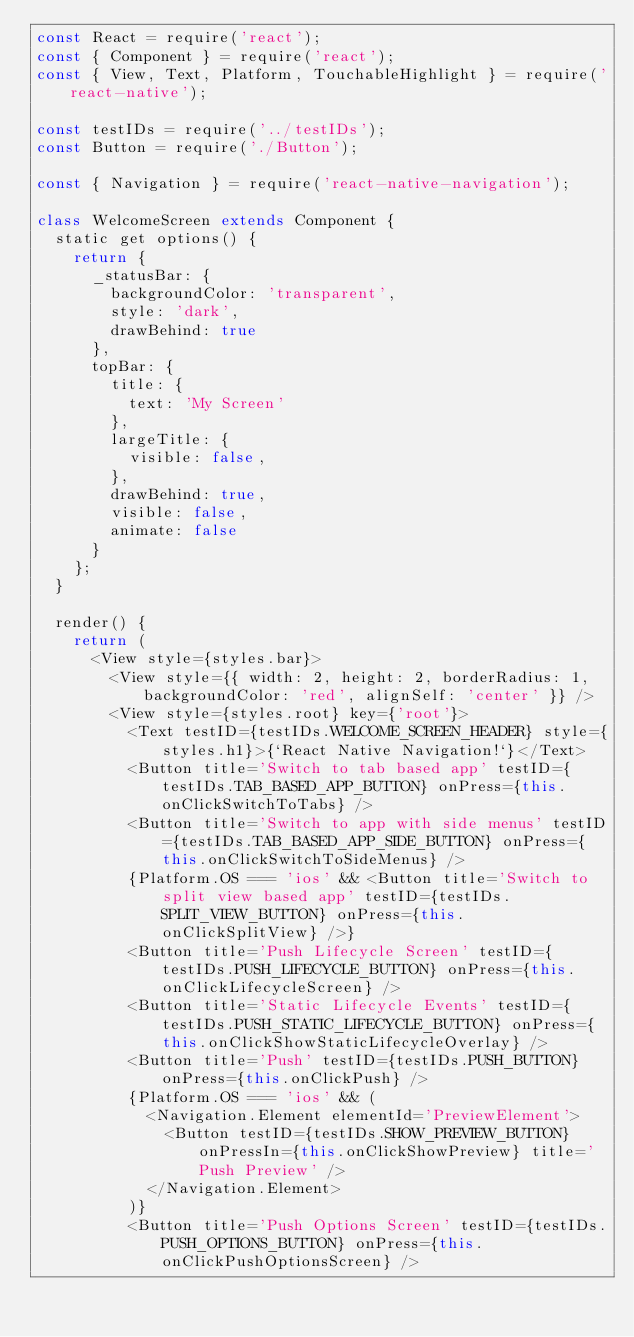<code> <loc_0><loc_0><loc_500><loc_500><_JavaScript_>const React = require('react');
const { Component } = require('react');
const { View, Text, Platform, TouchableHighlight } = require('react-native');

const testIDs = require('../testIDs');
const Button = require('./Button');

const { Navigation } = require('react-native-navigation');

class WelcomeScreen extends Component {
  static get options() {
    return {
      _statusBar: {
        backgroundColor: 'transparent',
        style: 'dark',
        drawBehind: true
      },
      topBar: {
        title: {
          text: 'My Screen'
        },
        largeTitle: {
          visible: false,
        },
        drawBehind: true,
        visible: false,
        animate: false
      }
    };
  }

  render() {
    return (
      <View style={styles.bar}>
        <View style={{ width: 2, height: 2, borderRadius: 1, backgroundColor: 'red', alignSelf: 'center' }} />
        <View style={styles.root} key={'root'}>
          <Text testID={testIDs.WELCOME_SCREEN_HEADER} style={styles.h1}>{`React Native Navigation!`}</Text>
          <Button title='Switch to tab based app' testID={testIDs.TAB_BASED_APP_BUTTON} onPress={this.onClickSwitchToTabs} />
          <Button title='Switch to app with side menus' testID={testIDs.TAB_BASED_APP_SIDE_BUTTON} onPress={this.onClickSwitchToSideMenus} />
          {Platform.OS === 'ios' && <Button title='Switch to split view based app' testID={testIDs.SPLIT_VIEW_BUTTON} onPress={this.onClickSplitView} />}
          <Button title='Push Lifecycle Screen' testID={testIDs.PUSH_LIFECYCLE_BUTTON} onPress={this.onClickLifecycleScreen} />
          <Button title='Static Lifecycle Events' testID={testIDs.PUSH_STATIC_LIFECYCLE_BUTTON} onPress={this.onClickShowStaticLifecycleOverlay} />
          <Button title='Push' testID={testIDs.PUSH_BUTTON} onPress={this.onClickPush} />
          {Platform.OS === 'ios' && (
            <Navigation.Element elementId='PreviewElement'>
              <Button testID={testIDs.SHOW_PREVIEW_BUTTON} onPressIn={this.onClickShowPreview} title='Push Preview' />
            </Navigation.Element>
          )}
          <Button title='Push Options Screen' testID={testIDs.PUSH_OPTIONS_BUTTON} onPress={this.onClickPushOptionsScreen} /></code> 